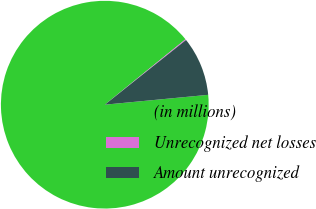Convert chart to OTSL. <chart><loc_0><loc_0><loc_500><loc_500><pie_chart><fcel>(in millions)<fcel>Unrecognized net losses<fcel>Amount unrecognized<nl><fcel>90.68%<fcel>0.14%<fcel>9.19%<nl></chart> 